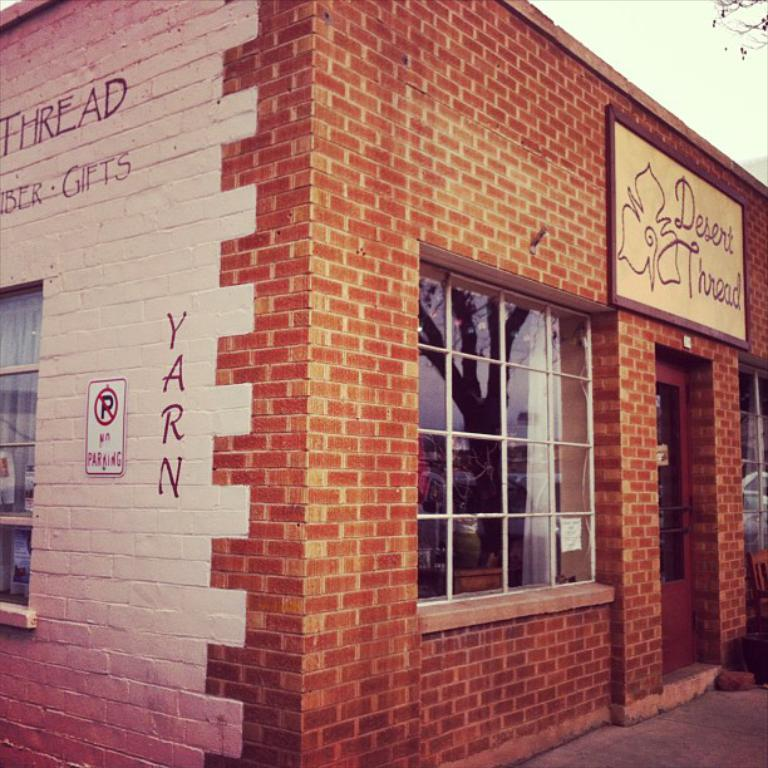What type of structure is in the picture? There is a house in the picture. What material is used for the wall of the house? The house has a brick wall. Are there any openings in the house for light and ventilation? Yes, there are windows in the house. What is written or displayed on the wall of the house? There is some text visible on the wall and a sign board on the wall. How would you describe the weather based on the sky in the picture? The sky is cloudy in the picture. How long does it take for the game to finish in the image? There is no game present in the image, so it is not possible to determine how long it would take to finish. 